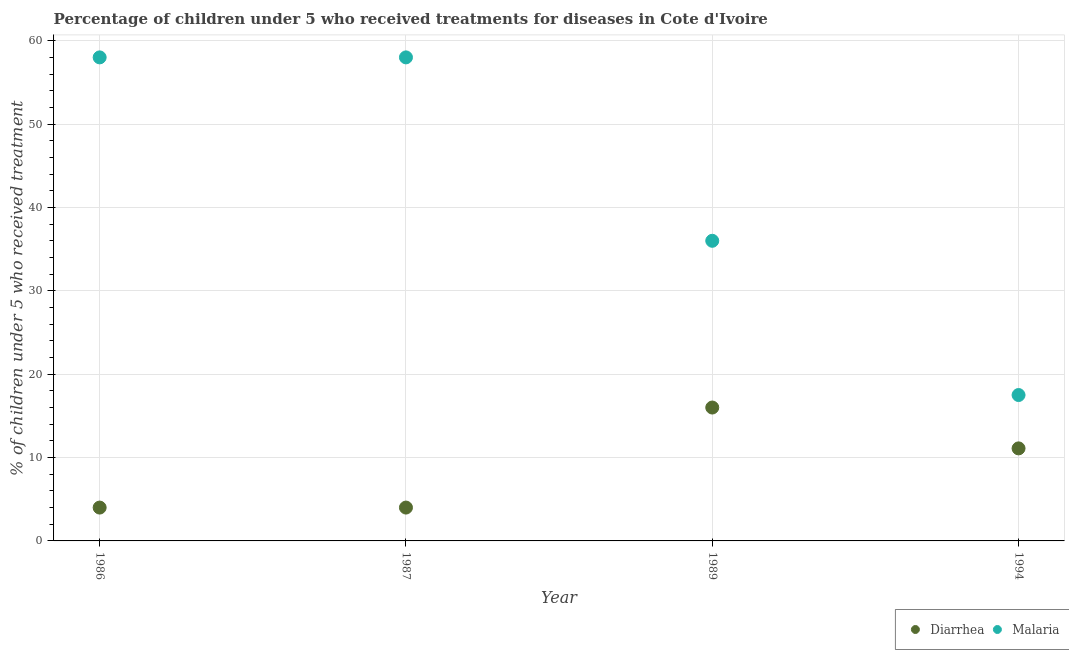Is the number of dotlines equal to the number of legend labels?
Your answer should be compact. Yes. What is the percentage of children who received treatment for malaria in 1994?
Provide a succinct answer. 17.5. Across all years, what is the maximum percentage of children who received treatment for malaria?
Keep it short and to the point. 58. What is the total percentage of children who received treatment for malaria in the graph?
Give a very brief answer. 169.5. What is the difference between the percentage of children who received treatment for diarrhoea in 1987 and that in 1994?
Make the answer very short. -7.1. What is the difference between the percentage of children who received treatment for diarrhoea in 1994 and the percentage of children who received treatment for malaria in 1986?
Provide a succinct answer. -46.9. What is the average percentage of children who received treatment for malaria per year?
Your answer should be very brief. 42.38. In the year 1989, what is the difference between the percentage of children who received treatment for malaria and percentage of children who received treatment for diarrhoea?
Your answer should be compact. 20. In how many years, is the percentage of children who received treatment for malaria greater than 42 %?
Provide a short and direct response. 2. What is the ratio of the percentage of children who received treatment for malaria in 1989 to that in 1994?
Offer a very short reply. 2.06. Is the difference between the percentage of children who received treatment for malaria in 1989 and 1994 greater than the difference between the percentage of children who received treatment for diarrhoea in 1989 and 1994?
Keep it short and to the point. Yes. What is the difference between the highest and the second highest percentage of children who received treatment for malaria?
Give a very brief answer. 0. What is the difference between the highest and the lowest percentage of children who received treatment for malaria?
Offer a very short reply. 40.5. Is the sum of the percentage of children who received treatment for malaria in 1986 and 1994 greater than the maximum percentage of children who received treatment for diarrhoea across all years?
Offer a very short reply. Yes. Is the percentage of children who received treatment for malaria strictly greater than the percentage of children who received treatment for diarrhoea over the years?
Offer a very short reply. Yes. How many dotlines are there?
Your answer should be very brief. 2. How many years are there in the graph?
Keep it short and to the point. 4. Does the graph contain any zero values?
Give a very brief answer. No. Where does the legend appear in the graph?
Ensure brevity in your answer.  Bottom right. What is the title of the graph?
Provide a succinct answer. Percentage of children under 5 who received treatments for diseases in Cote d'Ivoire. Does "Male entrants" appear as one of the legend labels in the graph?
Give a very brief answer. No. What is the label or title of the Y-axis?
Offer a very short reply. % of children under 5 who received treatment. What is the % of children under 5 who received treatment in Diarrhea in 1986?
Provide a succinct answer. 4. What is the % of children under 5 who received treatment in Malaria in 1986?
Offer a very short reply. 58. What is the % of children under 5 who received treatment in Diarrhea in 1987?
Provide a succinct answer. 4. What is the % of children under 5 who received treatment of Malaria in 1989?
Offer a very short reply. 36. Across all years, what is the maximum % of children under 5 who received treatment of Diarrhea?
Ensure brevity in your answer.  16. Across all years, what is the maximum % of children under 5 who received treatment in Malaria?
Provide a short and direct response. 58. Across all years, what is the minimum % of children under 5 who received treatment of Diarrhea?
Keep it short and to the point. 4. What is the total % of children under 5 who received treatment in Diarrhea in the graph?
Provide a succinct answer. 35.1. What is the total % of children under 5 who received treatment in Malaria in the graph?
Your answer should be very brief. 169.5. What is the difference between the % of children under 5 who received treatment in Malaria in 1986 and that in 1994?
Offer a terse response. 40.5. What is the difference between the % of children under 5 who received treatment in Malaria in 1987 and that in 1989?
Your response must be concise. 22. What is the difference between the % of children under 5 who received treatment in Diarrhea in 1987 and that in 1994?
Offer a terse response. -7.1. What is the difference between the % of children under 5 who received treatment of Malaria in 1987 and that in 1994?
Ensure brevity in your answer.  40.5. What is the difference between the % of children under 5 who received treatment in Malaria in 1989 and that in 1994?
Your answer should be compact. 18.5. What is the difference between the % of children under 5 who received treatment of Diarrhea in 1986 and the % of children under 5 who received treatment of Malaria in 1987?
Your response must be concise. -54. What is the difference between the % of children under 5 who received treatment in Diarrhea in 1986 and the % of children under 5 who received treatment in Malaria in 1989?
Your answer should be very brief. -32. What is the difference between the % of children under 5 who received treatment in Diarrhea in 1986 and the % of children under 5 who received treatment in Malaria in 1994?
Your answer should be very brief. -13.5. What is the difference between the % of children under 5 who received treatment in Diarrhea in 1987 and the % of children under 5 who received treatment in Malaria in 1989?
Your response must be concise. -32. What is the difference between the % of children under 5 who received treatment of Diarrhea in 1987 and the % of children under 5 who received treatment of Malaria in 1994?
Make the answer very short. -13.5. What is the average % of children under 5 who received treatment in Diarrhea per year?
Make the answer very short. 8.78. What is the average % of children under 5 who received treatment of Malaria per year?
Ensure brevity in your answer.  42.38. In the year 1986, what is the difference between the % of children under 5 who received treatment of Diarrhea and % of children under 5 who received treatment of Malaria?
Offer a terse response. -54. In the year 1987, what is the difference between the % of children under 5 who received treatment in Diarrhea and % of children under 5 who received treatment in Malaria?
Keep it short and to the point. -54. What is the ratio of the % of children under 5 who received treatment in Malaria in 1986 to that in 1989?
Ensure brevity in your answer.  1.61. What is the ratio of the % of children under 5 who received treatment in Diarrhea in 1986 to that in 1994?
Provide a short and direct response. 0.36. What is the ratio of the % of children under 5 who received treatment of Malaria in 1986 to that in 1994?
Your answer should be very brief. 3.31. What is the ratio of the % of children under 5 who received treatment in Diarrhea in 1987 to that in 1989?
Ensure brevity in your answer.  0.25. What is the ratio of the % of children under 5 who received treatment in Malaria in 1987 to that in 1989?
Your response must be concise. 1.61. What is the ratio of the % of children under 5 who received treatment in Diarrhea in 1987 to that in 1994?
Provide a succinct answer. 0.36. What is the ratio of the % of children under 5 who received treatment in Malaria in 1987 to that in 1994?
Ensure brevity in your answer.  3.31. What is the ratio of the % of children under 5 who received treatment in Diarrhea in 1989 to that in 1994?
Offer a very short reply. 1.44. What is the ratio of the % of children under 5 who received treatment in Malaria in 1989 to that in 1994?
Ensure brevity in your answer.  2.06. What is the difference between the highest and the second highest % of children under 5 who received treatment in Malaria?
Keep it short and to the point. 0. What is the difference between the highest and the lowest % of children under 5 who received treatment of Malaria?
Give a very brief answer. 40.5. 